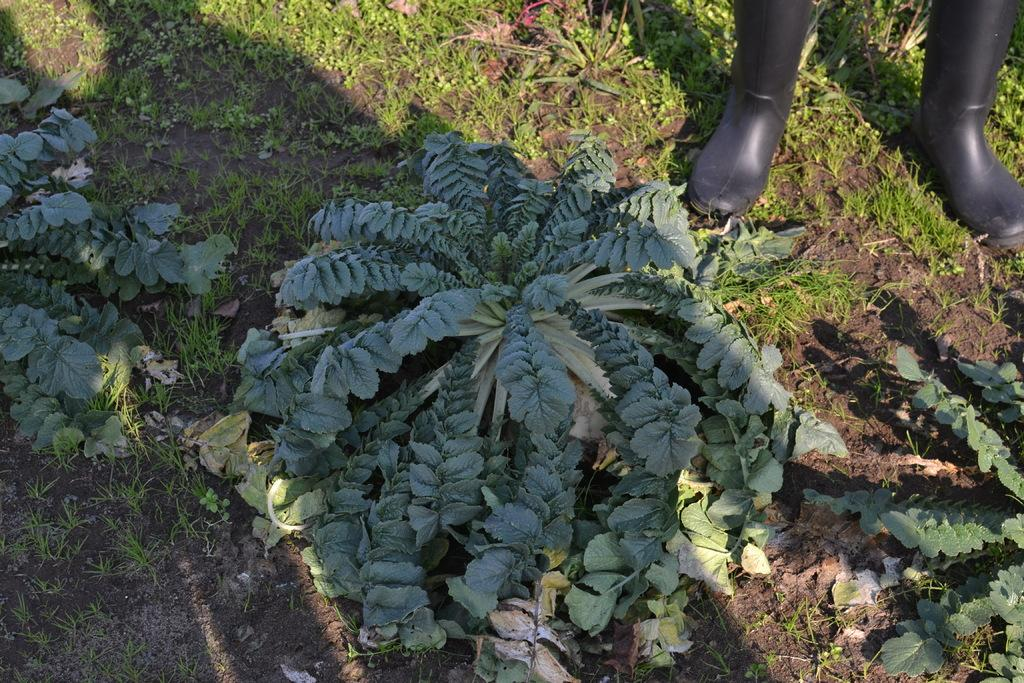What type of footwear is on the ground in the image? There is a pair of boots on the ground in the image. What type of vegetation can be seen in the image? There are shrubs and grass in the image. What type of engine can be seen powering the boots in the image? There is no engine present in the image, and the boots are not powered by any engine. Can you tell me how the boots are breathing in the image? Boots do not breathe, so this question does not apply to the image. 